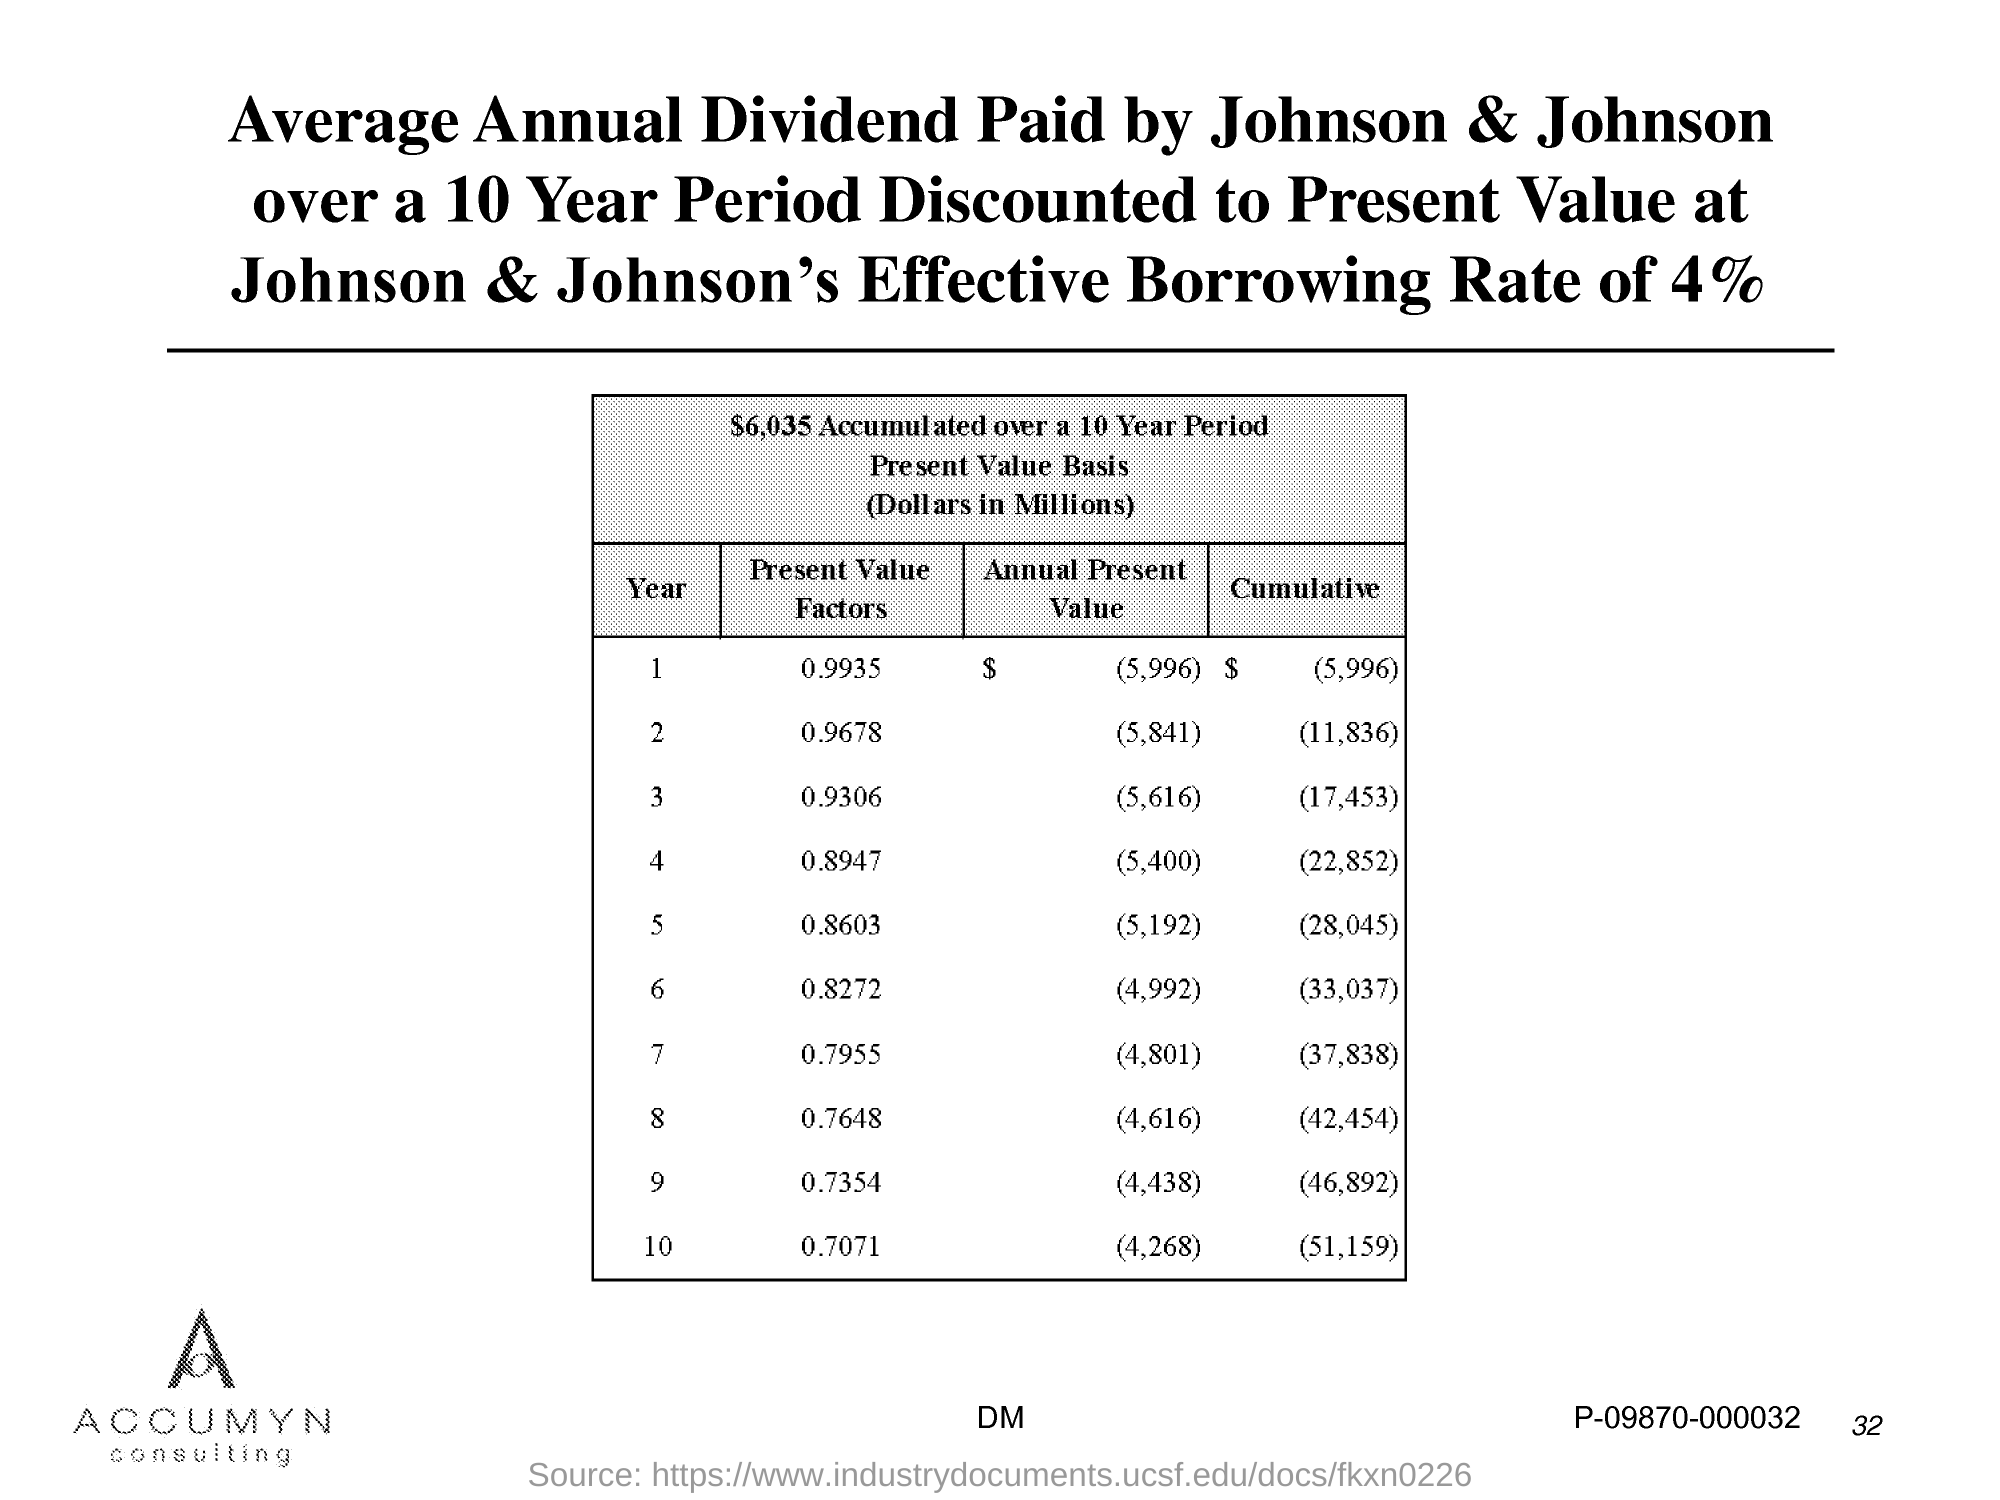Mention a couple of crucial points in this snapshot. The page number is 32," the speaker declared. 